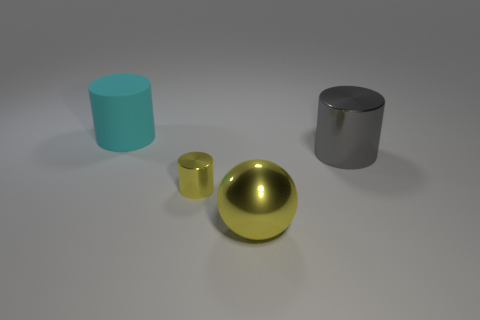Add 1 blue shiny balls. How many objects exist? 5 Subtract all cylinders. How many objects are left? 1 Add 2 large yellow metal spheres. How many large yellow metal spheres are left? 3 Add 3 blue rubber blocks. How many blue rubber blocks exist? 3 Subtract 0 cyan balls. How many objects are left? 4 Subtract all large yellow metallic spheres. Subtract all tiny purple cylinders. How many objects are left? 3 